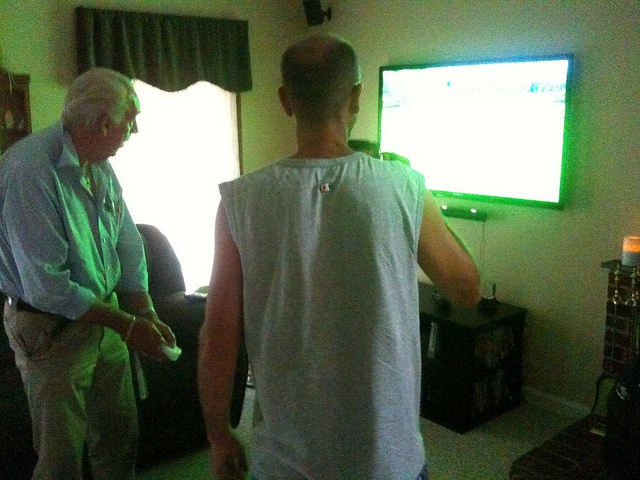Describe the objects in this image and their specific colors. I can see people in green, black, gray, and darkgreen tones, people in green, black, gray, teal, and darkgreen tones, tv in green, white, and darkgreen tones, couch in green, black, gray, darkgray, and darkgreen tones, and remote in green and darkgreen tones in this image. 